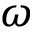<formula> <loc_0><loc_0><loc_500><loc_500>{ \omega }</formula> 